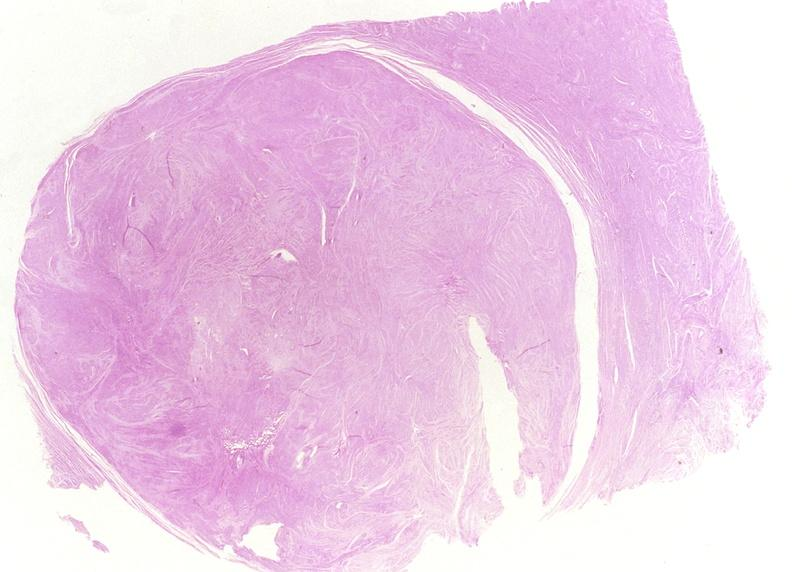what does this image show?
Answer the question using a single word or phrase. Leiomyoma 